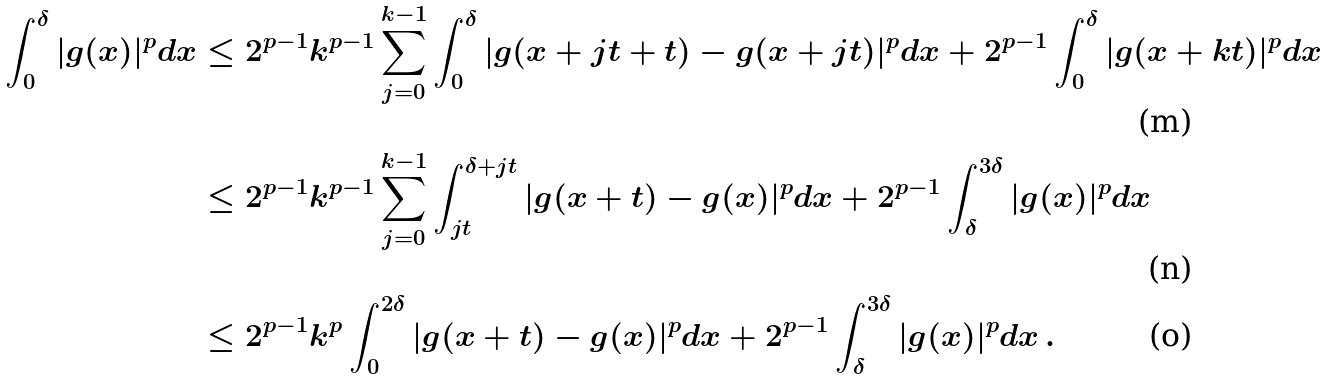<formula> <loc_0><loc_0><loc_500><loc_500>\int _ { 0 } ^ { \delta } | g ( x ) | ^ { p } d x & \leq 2 ^ { p - 1 } k ^ { p - 1 } \sum _ { j = 0 } ^ { k - 1 } \int _ { 0 } ^ { \delta } | g ( x + j t + t ) - g ( x + j t ) | ^ { p } d x + 2 ^ { p - 1 } \int _ { 0 } ^ { \delta } | g ( x + k t ) | ^ { p } d x \\ & \leq 2 ^ { p - 1 } k ^ { p - 1 } \sum _ { j = 0 } ^ { k - 1 } \int _ { j t } ^ { \delta + j t } | g ( x + t ) - g ( x ) | ^ { p } d x + 2 ^ { p - 1 } \int _ { \delta } ^ { 3 \delta } | g ( x ) | ^ { p } d x \\ & \leq 2 ^ { p - 1 } k ^ { p } \int _ { 0 } ^ { 2 \delta } | g ( x + t ) - g ( x ) | ^ { p } d x + 2 ^ { p - 1 } \int _ { \delta } ^ { 3 \delta } | g ( x ) | ^ { p } d x \, .</formula> 